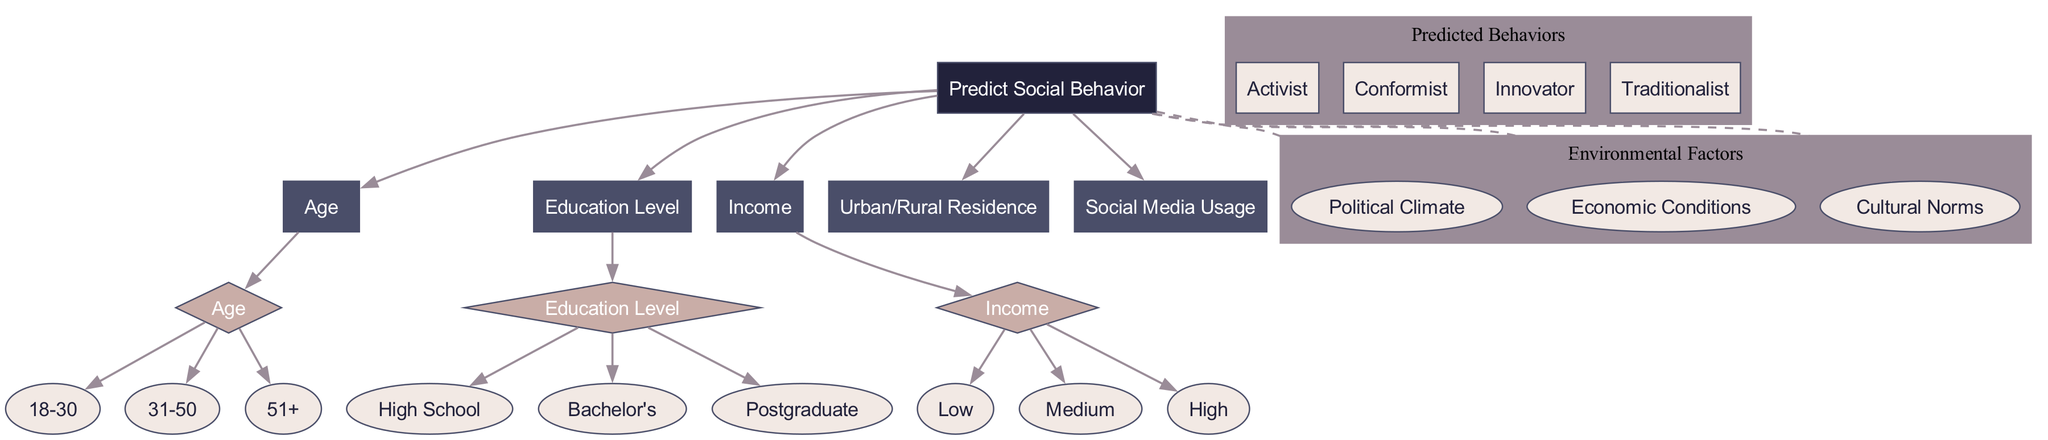What is the root node of the diagram? The root node is labeled "Predict Social Behavior," which is the starting point of the decision-making process in the diagram.
Answer: Predict Social Behavior How many features are displayed in the diagram? There are five features listed in the diagram that contribute to predicting social behavior.
Answer: 5 What type of node is "Age"? "Age" is a decision node because it branches into different groups that help determine the outcome based on that feature.
Answer: Decision node What are the three branches stemming from the "Income" decision node? The branches from the "Income" decision node are "Low," "Medium," and "High," which categorize the income levels of individuals.
Answer: Low, Medium, High Which predicted behavior is linked to the demographic characteristics of older individuals? The older demographics (51+) are more likely to fall into the "Traditionalist" predicted behavior category as inferred from the decision tree structure.
Answer: Traditionalist How many predicted behaviors (leaf nodes) are listed in the diagram? There are four predicted behaviors listed as leaf nodes at the conclusion of the decision tree process.
Answer: 4 What connects the environmental factors to the root node? The environmental factors connect to the root node with dashed edges, indicating their influence on the prediction of social behavior without being direct decision criteria.
Answer: Dashed edges If someone is in the "Bachelor's" education category, what decision node do they encounter next? After selecting the "Bachelor's" education category, the individual would encounter the next decision node labeled "Income" to further classify their social behavior.
Answer: Income What are the environmental factors considered in predicting social behavior? The environmental factors considered include "Political Climate," "Economic Conditions," and "Cultural Norms," which provide context for the demographic analysis in the prediction model.
Answer: Political Climate, Economic Conditions, Cultural Norms 